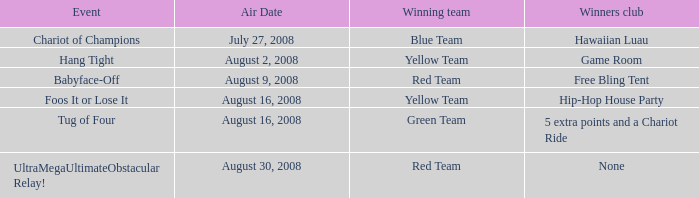Which Week has an Air Date of august 2, 2008? 2.0. Give me the full table as a dictionary. {'header': ['Event', 'Air Date', 'Winning team', 'Winners club'], 'rows': [['Chariot of Champions', 'July 27, 2008', 'Blue Team', 'Hawaiian Luau'], ['Hang Tight', 'August 2, 2008', 'Yellow Team', 'Game Room'], ['Babyface-Off', 'August 9, 2008', 'Red Team', 'Free Bling Tent'], ['Foos It or Lose It', 'August 16, 2008', 'Yellow Team', 'Hip-Hop House Party'], ['Tug of Four', 'August 16, 2008', 'Green Team', '5 extra points and a Chariot Ride'], ['UltraMegaUltimateObstacular Relay!', 'August 30, 2008', 'Red Team', 'None']]} 